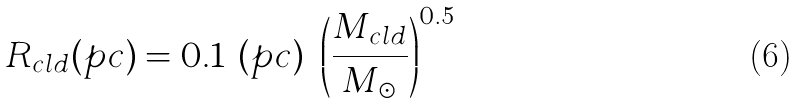<formula> <loc_0><loc_0><loc_500><loc_500>R _ { c l d } ( p c ) = 0 . 1 \ ( p c ) \ \left ( \frac { M _ { c l d } } { M _ { \odot } } \right ) ^ { 0 . 5 }</formula> 